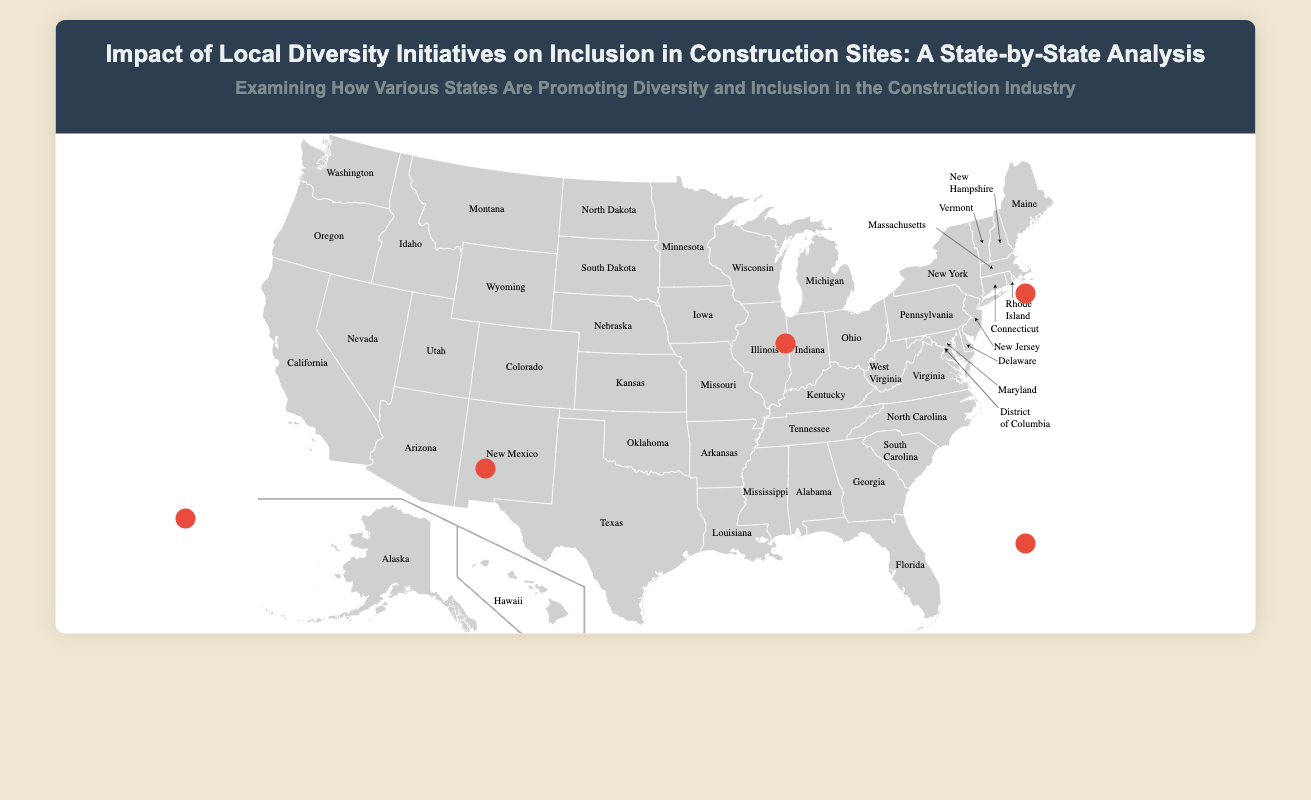What program is used in California? The California Diversity Council Initiatives are implemented to promote diversity in construction.
Answer: California Diversity Council Initiatives What was the minority representation increase in Illinois? Over 1,000 participants were trained in Illinois, contributing to its diversity initiatives.
Answer: 80% How much has veteran participation increased in Florida? Florida's Construction Diversity Initiative notes a rise in veteran hiring.
Answer: 10% What percentage of new contracts are awarded to minority-owned businesses in New York? A significant percentage of contracts has been awarded to minority contractors as part of the inclusion initiatives.
Answer: 30% What is the training participation rate in Texas? The Texas Workforce Commission's Diversity Program reports a high engagement in training among workers.
Answer: 75% What are the Illinois Tollway's ConstructionWorks Program aimed at? Illinois is focused on increasing diversity through various training initiatives for specific groups.
Answer: Minority groups What initiatives support women in construction in Florida? Florida's initiatives focus on women and veterans, notably through various programs dedicated to mentoring.
Answer: Women Mentorship Programs What impact has New York's inclusion initiative had on discrimination complaints? The initiative has effectively reduced the number of complaints about discrimination at worksites.
Answer: Decrease by 20% 